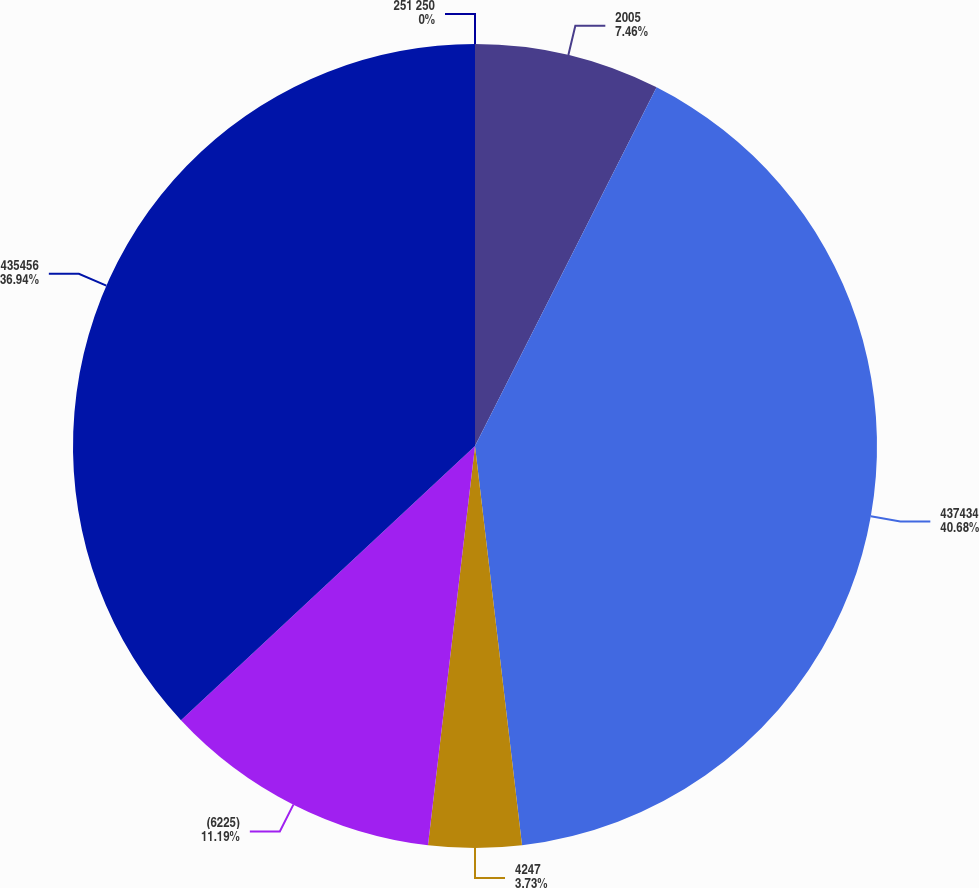Convert chart. <chart><loc_0><loc_0><loc_500><loc_500><pie_chart><fcel>2005<fcel>437434<fcel>4247<fcel>(6225)<fcel>435456<fcel>251 250<nl><fcel>7.46%<fcel>40.67%<fcel>3.73%<fcel>11.19%<fcel>36.94%<fcel>0.0%<nl></chart> 